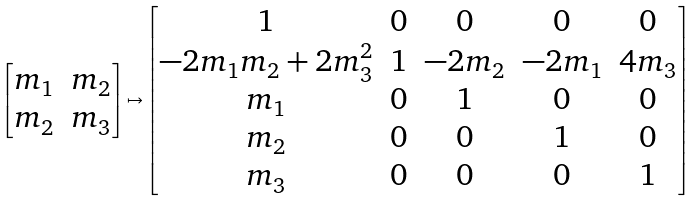Convert formula to latex. <formula><loc_0><loc_0><loc_500><loc_500>\begin{bmatrix} m _ { 1 } & m _ { 2 } \\ m _ { 2 } & m _ { 3 } \end{bmatrix} \mapsto \begin{bmatrix} 1 & 0 & 0 & 0 & 0 \\ - 2 m _ { 1 } m _ { 2 } + 2 m _ { 3 } ^ { 2 } & 1 & - 2 m _ { 2 } & - 2 m _ { 1 } & 4 m _ { 3 } \\ m _ { 1 } & 0 & 1 & 0 & 0 \\ m _ { 2 } & 0 & 0 & 1 & 0 \\ m _ { 3 } & 0 & 0 & 0 & 1 \\ \end{bmatrix}</formula> 